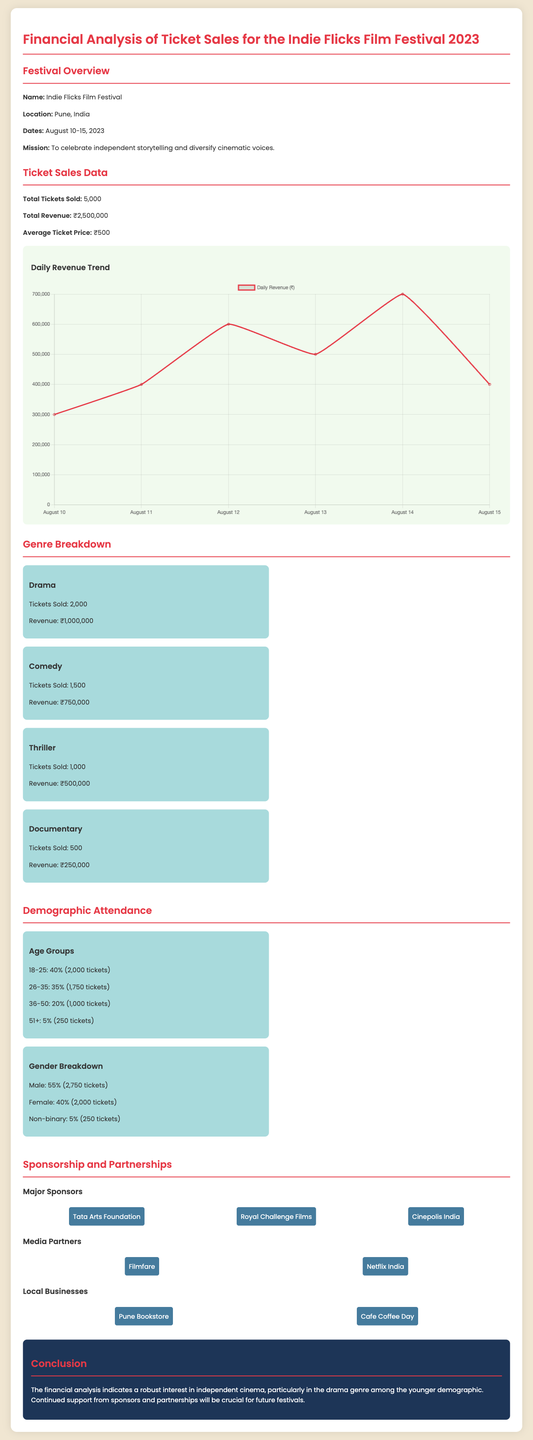what is the total number of tickets sold? The total number of tickets sold is provided in the ticket sales data section of the document.
Answer: 5,000 what is the total revenue generated? The total revenue is stated in the ticket sales data section of the document.
Answer: ₹2,500,000 how much revenue did the Drama genre generate? The revenue for the Drama genre is specified under the genre breakdown section of the document.
Answer: ₹1,000,000 what percentage of attendees were aged 18-25? The percentage of attendees in this age group is displayed in the demographic attendance section.
Answer: 40% who is a major sponsor of the festival? Major sponsors are listed in the sponsorship and partnerships section of the document.
Answer: Tata Arts Foundation which genre had the least tickets sold? The genre with the least tickets sold is indicated in the genre breakdown section.
Answer: Documentary how many tickets were sold to the 26-35 age group? The number of tickets sold to this age group is detailed in the demographic attendance section.
Answer: 1,750 tickets what is the average ticket price? The average ticket price is mentioned in the ticket sales data section of the financial analysis.
Answer: ₹500 